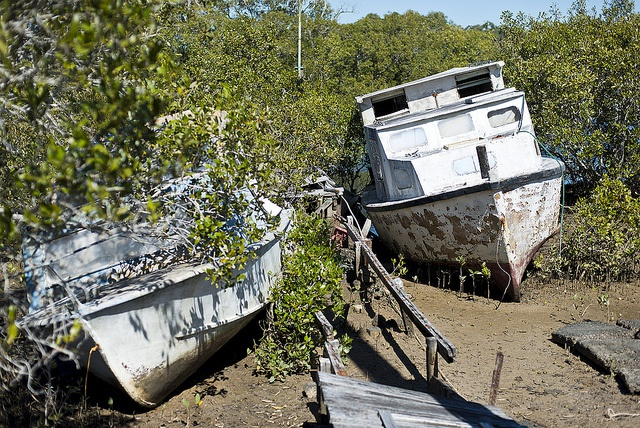Describe the objects in this image and their specific colors. I can see boat in black, lightgray, gray, and darkgray tones and boat in black, white, gray, and darkgray tones in this image. 